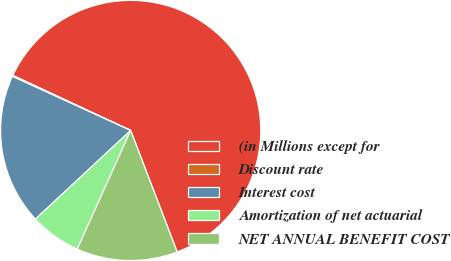Convert chart to OTSL. <chart><loc_0><loc_0><loc_500><loc_500><pie_chart><fcel>(in Millions except for<fcel>Discount rate<fcel>Interest cost<fcel>Amortization of net actuarial<fcel>NET ANNUAL BENEFIT COST<nl><fcel>62.22%<fcel>0.13%<fcel>18.76%<fcel>6.34%<fcel>12.55%<nl></chart> 